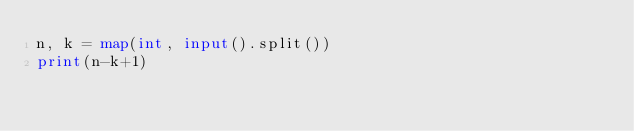Convert code to text. <code><loc_0><loc_0><loc_500><loc_500><_Python_>n, k = map(int, input().split())
print(n-k+1)</code> 